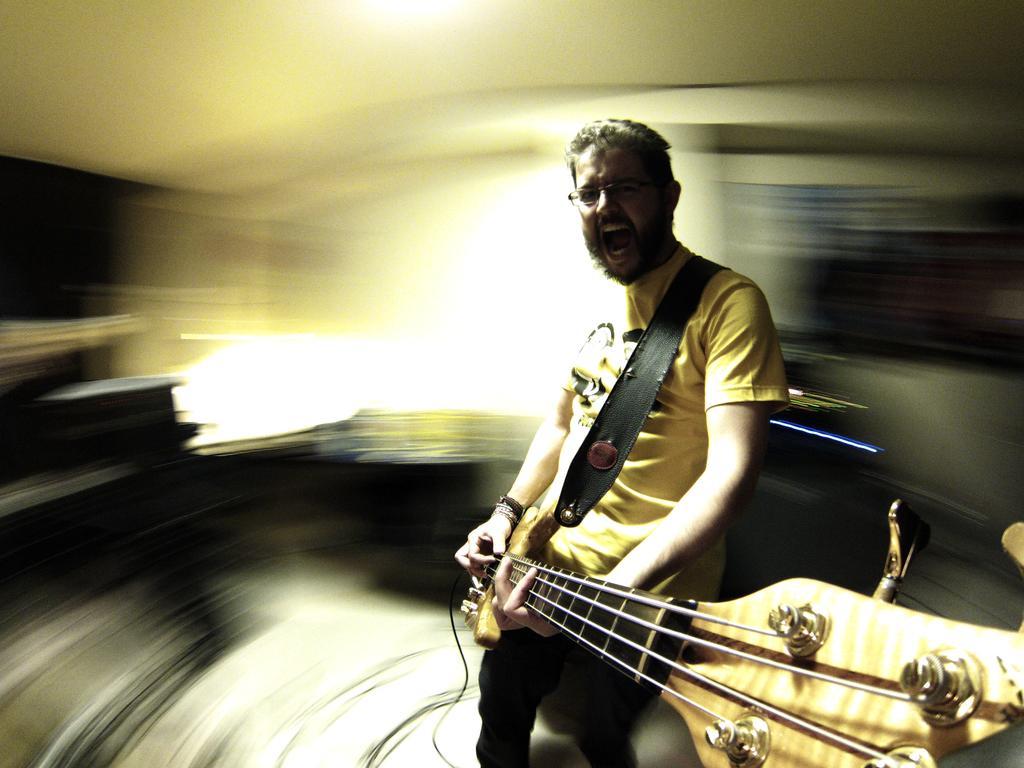How would you summarize this image in a sentence or two? In this image I see a man who is holding the guitar. 